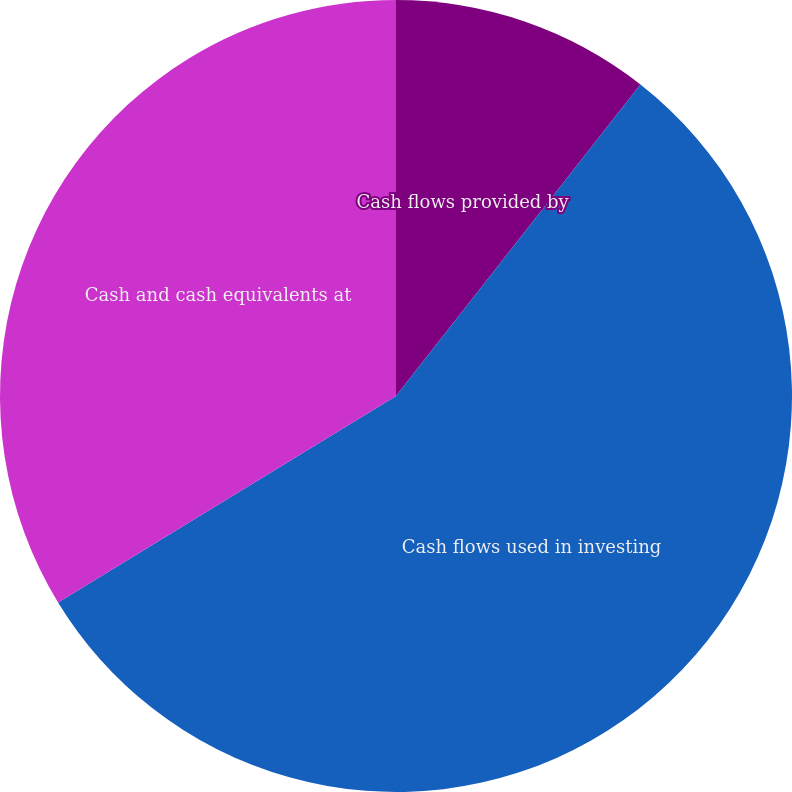Convert chart. <chart><loc_0><loc_0><loc_500><loc_500><pie_chart><fcel>Cash flows provided by<fcel>Cash flows used in investing<fcel>Cash and cash equivalents at<nl><fcel>10.59%<fcel>55.69%<fcel>33.73%<nl></chart> 